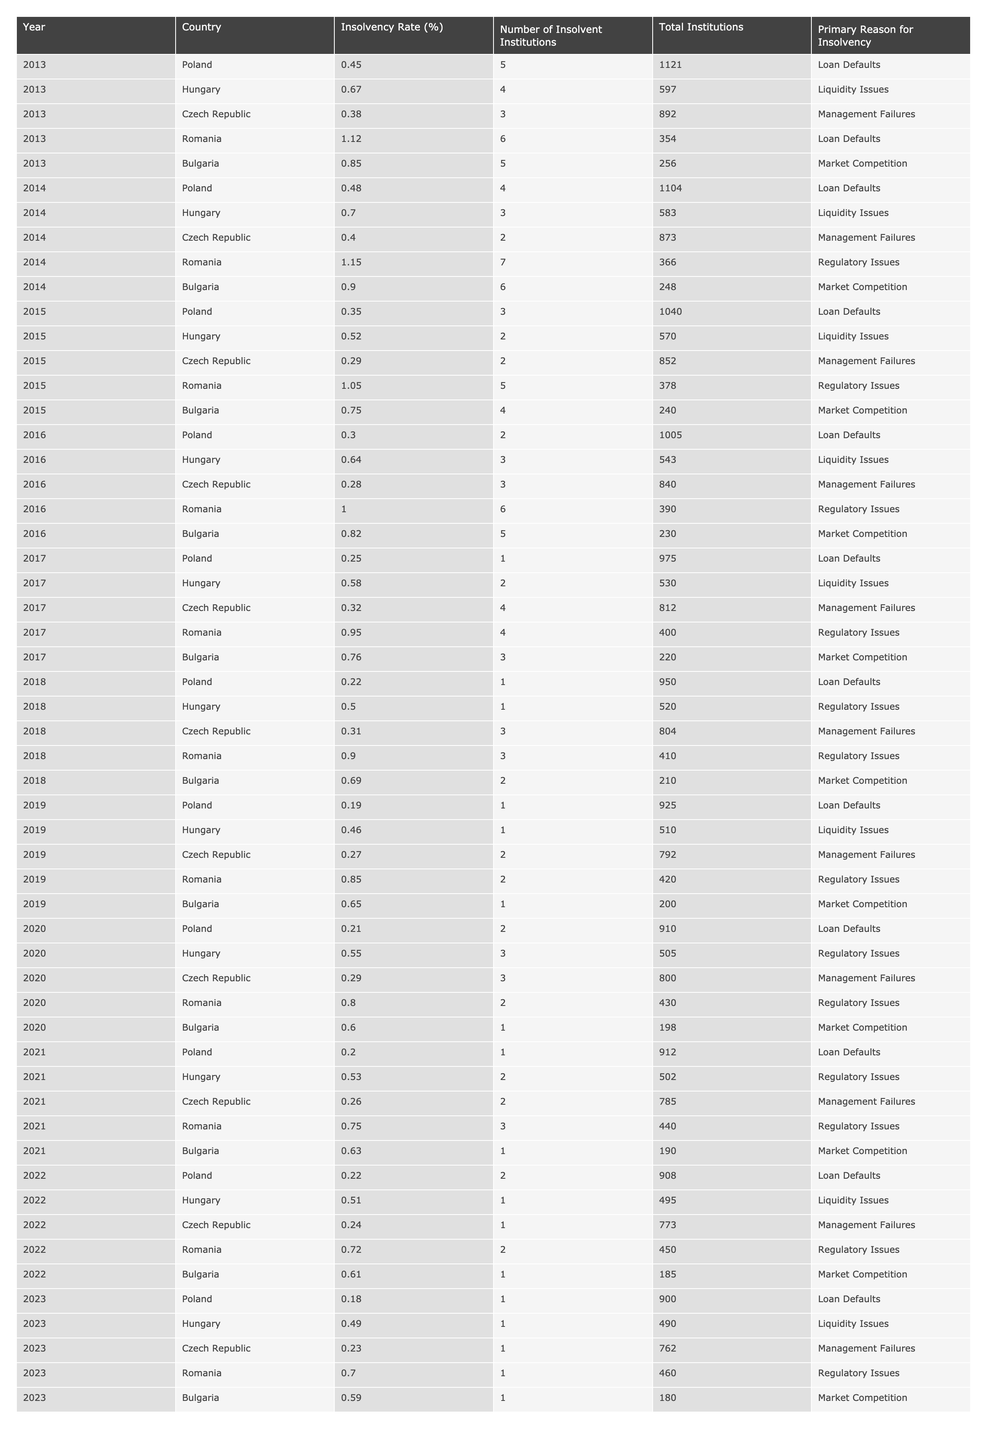What was the insolvency rate of Poland in 2019? According to the table, the insolvency rate for Poland in 2019 is 0.19%.
Answer: 0.19% Which country had the highest insolvency rate in 2014? By reviewing the data, Romania had the highest insolvency rate in 2014 at 1.15%.
Answer: Romania What is the total number of insolvent institutions in Hungary from 2013 to 2023? Summing the values over these years gives: 4 + 3 + 2 + 3 + 2 + 1 + 1 + 1 + 1 = 18 insolvent institutions in total.
Answer: 18 What primary reason for insolvency appears most frequently in the table? By scanning the table, 'Loan Defaults' is the primary reason for insolvency reported multiple times.
Answer: Loan Defaults Did any country have an insolvency rate below 0.25% in the years provided? Yes, Poland had an insolvency rate below 0.25% in 2017 (0.25%) and 2018 (0.22%).
Answer: Yes What was the average insolvency rate across all countries in 2020? Adding the insolvency rates for 2020 gives (0.21 + 0.55 + 0.29 + 0.80 + 0.60) = 2.45%, and dividing by the number of countries (5), the average is 0.49%.
Answer: 0.49% Which country consistently reported the least insolvency rate over the decade presented? Analyzing the table, Poland shows the least insolvency rate consistently over the years, going down to 0.18% in 2023.
Answer: Poland In what year did Hungary see the lowest number of insolvent institutions? The table indicates that Hungary had the lowest number of insolvent institutions in 2015, with just 2 institutions.
Answer: 2015 If we look at the total institutions in Romania in 2016, how many institutions were solvent? Romania had 390 total institutions in 2016. The number of insolvent institutions was 6. Therefore, the number of solvent institutions is 390 - 6 = 384.
Answer: 384 How did the insolvency rate of Bulgaria change from 2013 to 2023? In 2013 the rate was 0.85%, while in 2023 it declined to 0.59%. This indicates a decrease of 0.26% over the decade.
Answer: Decreased What percentage of total institutions in the Czech Republic were insolvent in 2021? In 2021, there were 2 insolvent institutions out of 785 total institutions. The calculation for percentage is (2 / 785) * 100 ≈ 0.25%.
Answer: 0.25% 